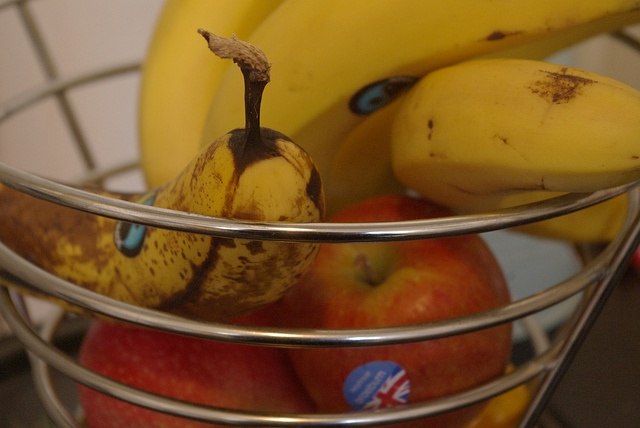Describe the objects in this image and their specific colors. I can see banana in gray, olive, and maroon tones, apple in gray, maroon, and black tones, and apple in gray and maroon tones in this image. 